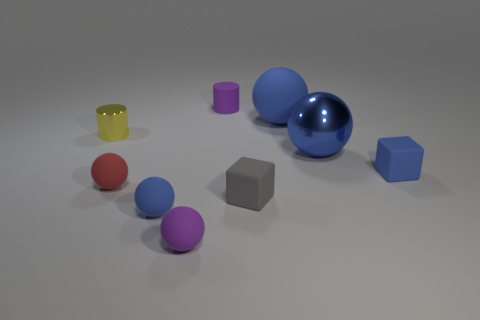What is the material of the ball that is the same color as the matte cylinder?
Keep it short and to the point. Rubber. There is a small thing that is the same color as the small matte cylinder; what shape is it?
Ensure brevity in your answer.  Sphere. Are there more tiny blue matte objects right of the tiny matte cylinder than red balls behind the metal ball?
Make the answer very short. Yes. There is a small yellow cylinder on the left side of the small purple cylinder; what number of small blue rubber blocks are on the left side of it?
Give a very brief answer. 0. What number of things are either large green metal blocks or blue objects?
Offer a very short reply. 4. Is the shape of the big matte thing the same as the small gray thing?
Your answer should be compact. No. What is the material of the small blue ball?
Keep it short and to the point. Rubber. What number of rubber objects are to the left of the large rubber ball and in front of the purple matte cylinder?
Offer a very short reply. 4. Is the red ball the same size as the purple rubber ball?
Provide a short and direct response. Yes. There is a blue rubber object on the right side of the metallic sphere; does it have the same size as the yellow shiny thing?
Make the answer very short. Yes. 